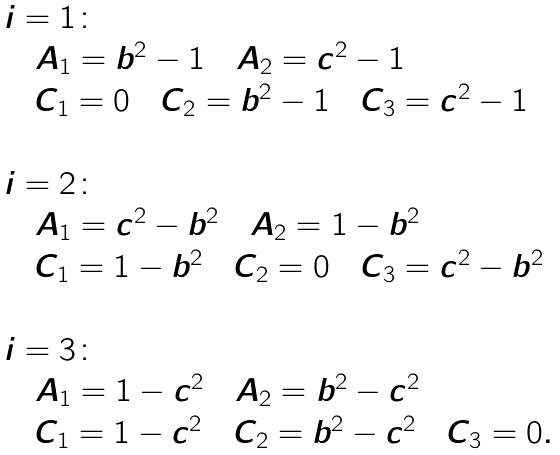Convert formula to latex. <formula><loc_0><loc_0><loc_500><loc_500>\begin{array} { l l } i = 1 \colon \\ \quad A _ { 1 } = b ^ { 2 } - 1 \quad A _ { 2 } = c ^ { 2 } - 1 \quad \\ \quad C _ { 1 } = 0 \quad C _ { 2 } = b ^ { 2 } - 1 \quad C _ { 3 } = c ^ { 2 } - 1 \\ \\ i = 2 \colon \\ \quad A _ { 1 } = c ^ { 2 } - b ^ { 2 } \quad A _ { 2 } = 1 - b ^ { 2 } \\ \quad C _ { 1 } = 1 - b ^ { 2 } \quad C _ { 2 } = 0 \quad C _ { 3 } = c ^ { 2 } - b ^ { 2 } \\ \\ i = 3 \colon \\ \quad A _ { 1 } = 1 - c ^ { 2 } \quad A _ { 2 } = b ^ { 2 } - c ^ { 2 } \\ \quad C _ { 1 } = 1 - c ^ { 2 } \quad C _ { 2 } = b ^ { 2 } - c ^ { 2 } \quad C _ { 3 } = 0 . \\ \\ \end{array}</formula> 